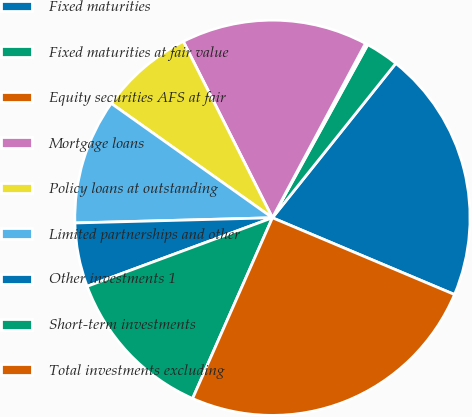Convert chart to OTSL. <chart><loc_0><loc_0><loc_500><loc_500><pie_chart><fcel>Fixed maturities<fcel>Fixed maturities at fair value<fcel>Equity securities AFS at fair<fcel>Mortgage loans<fcel>Policy loans at outstanding<fcel>Limited partnerships and other<fcel>Other investments 1<fcel>Short-term investments<fcel>Total investments excluding<nl><fcel>20.62%<fcel>2.72%<fcel>0.21%<fcel>15.25%<fcel>7.73%<fcel>10.24%<fcel>5.22%<fcel>12.74%<fcel>25.27%<nl></chart> 